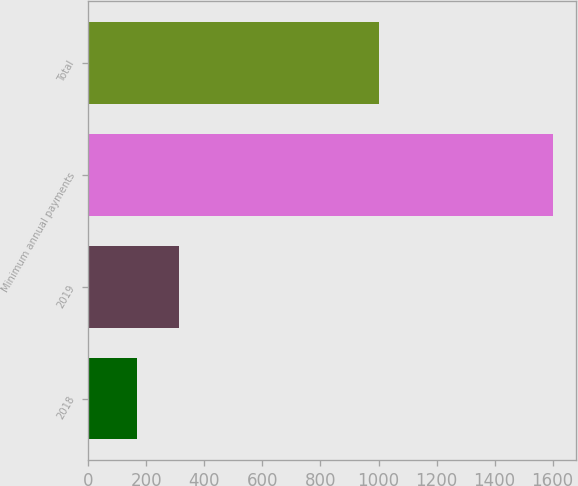Convert chart to OTSL. <chart><loc_0><loc_0><loc_500><loc_500><bar_chart><fcel>2018<fcel>2019<fcel>Minimum annual payments<fcel>Total<nl><fcel>168<fcel>311.3<fcel>1601<fcel>1000<nl></chart> 